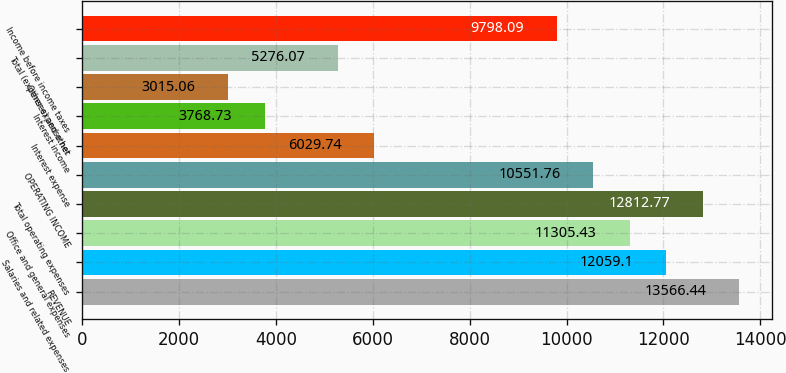Convert chart. <chart><loc_0><loc_0><loc_500><loc_500><bar_chart><fcel>REVENUE<fcel>Salaries and related expenses<fcel>Office and general expenses<fcel>Total operating expenses<fcel>OPERATING INCOME<fcel>Interest expense<fcel>Interest income<fcel>Other expense net<fcel>Total (expenses) and other<fcel>Income before income taxes<nl><fcel>13566.4<fcel>12059.1<fcel>11305.4<fcel>12812.8<fcel>10551.8<fcel>6029.74<fcel>3768.73<fcel>3015.06<fcel>5276.07<fcel>9798.09<nl></chart> 